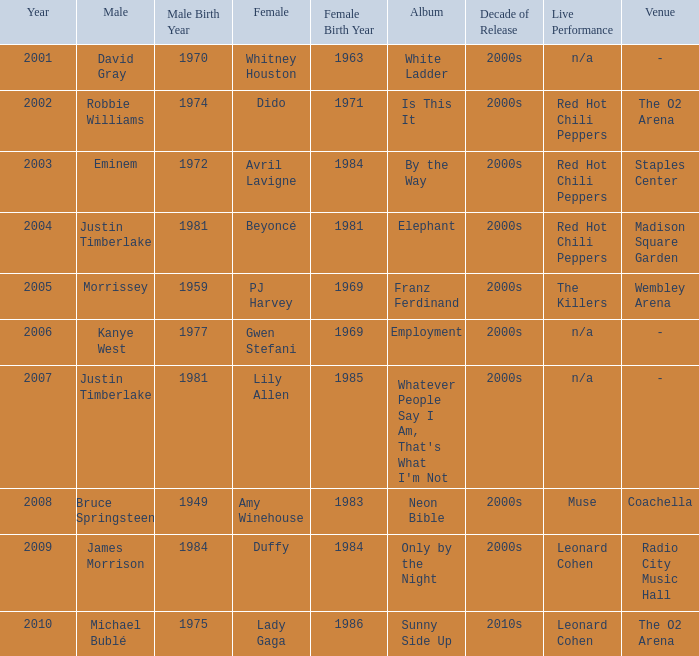Who is the male partner for amy winehouse? Bruce Springsteen. 